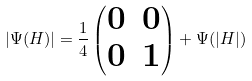<formula> <loc_0><loc_0><loc_500><loc_500>| \Psi ( H ) | = \frac { 1 } { 4 } \begin{pmatrix} 0 & 0 \\ 0 & 1 \end{pmatrix} + \Psi ( | H | )</formula> 